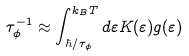Convert formula to latex. <formula><loc_0><loc_0><loc_500><loc_500>\tau _ { \phi } ^ { - 1 } \approx \int _ { { \hbar { / } \tau _ { \phi } } } ^ { k _ { B } T } { d { \varepsilon } K ( { \varepsilon } ) g ( { \varepsilon } ) }</formula> 